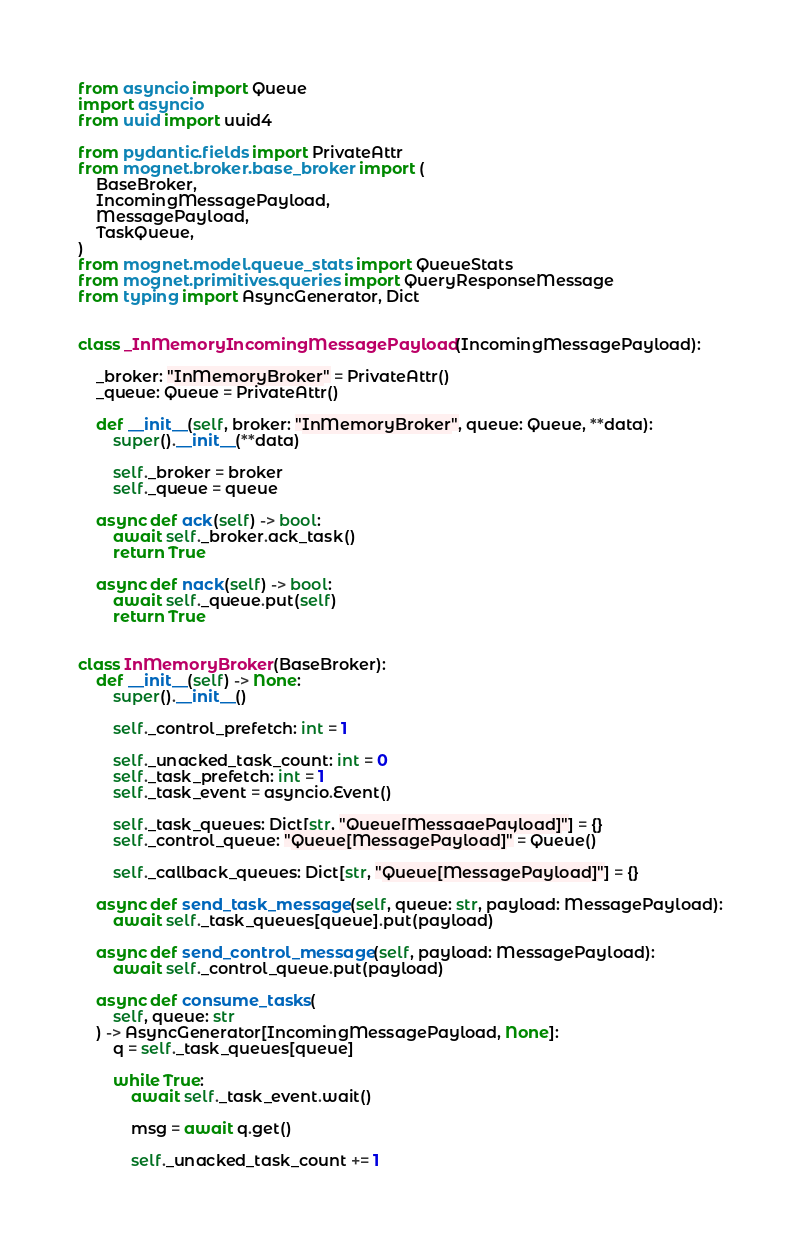Convert code to text. <code><loc_0><loc_0><loc_500><loc_500><_Python_>from asyncio import Queue
import asyncio
from uuid import uuid4

from pydantic.fields import PrivateAttr
from mognet.broker.base_broker import (
    BaseBroker,
    IncomingMessagePayload,
    MessagePayload,
    TaskQueue,
)
from mognet.model.queue_stats import QueueStats
from mognet.primitives.queries import QueryResponseMessage
from typing import AsyncGenerator, Dict


class _InMemoryIncomingMessagePayload(IncomingMessagePayload):

    _broker: "InMemoryBroker" = PrivateAttr()
    _queue: Queue = PrivateAttr()

    def __init__(self, broker: "InMemoryBroker", queue: Queue, **data):
        super().__init__(**data)

        self._broker = broker
        self._queue = queue

    async def ack(self) -> bool:
        await self._broker.ack_task()
        return True

    async def nack(self) -> bool:
        await self._queue.put(self)
        return True


class InMemoryBroker(BaseBroker):
    def __init__(self) -> None:
        super().__init__()

        self._control_prefetch: int = 1

        self._unacked_task_count: int = 0
        self._task_prefetch: int = 1
        self._task_event = asyncio.Event()

        self._task_queues: Dict[str, "Queue[MessagePayload]"] = {}
        self._control_queue: "Queue[MessagePayload]" = Queue()

        self._callback_queues: Dict[str, "Queue[MessagePayload]"] = {}

    async def send_task_message(self, queue: str, payload: MessagePayload):
        await self._task_queues[queue].put(payload)

    async def send_control_message(self, payload: MessagePayload):
        await self._control_queue.put(payload)

    async def consume_tasks(
        self, queue: str
    ) -> AsyncGenerator[IncomingMessagePayload, None]:
        q = self._task_queues[queue]

        while True:
            await self._task_event.wait()

            msg = await q.get()

            self._unacked_task_count += 1</code> 